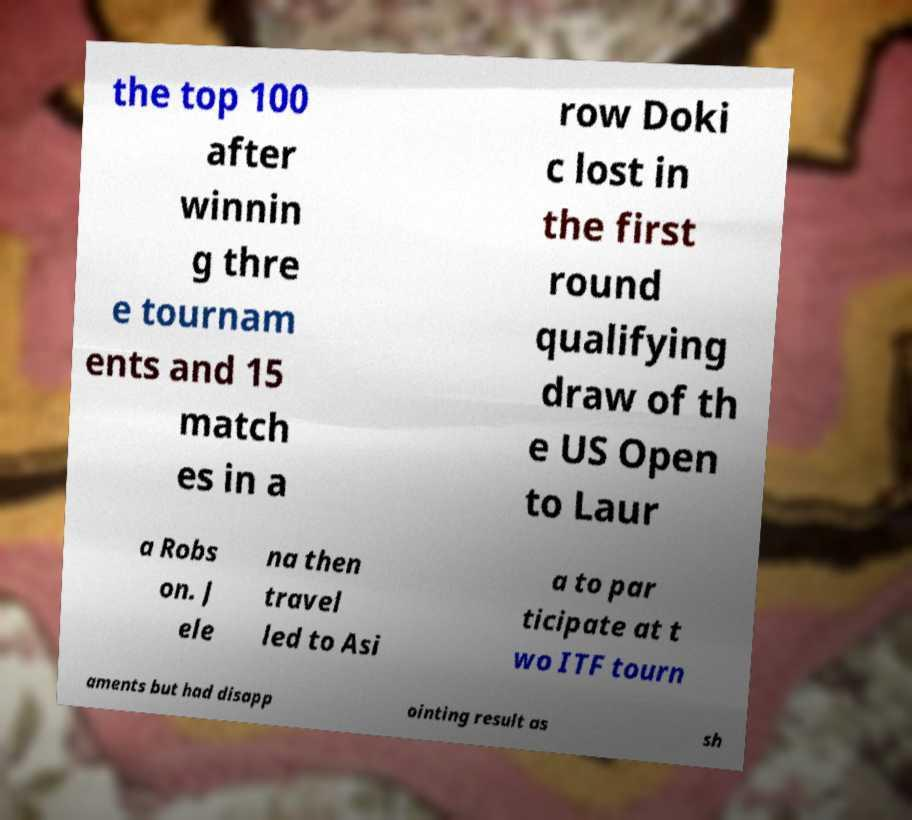For documentation purposes, I need the text within this image transcribed. Could you provide that? the top 100 after winnin g thre e tournam ents and 15 match es in a row Doki c lost in the first round qualifying draw of th e US Open to Laur a Robs on. J ele na then travel led to Asi a to par ticipate at t wo ITF tourn aments but had disapp ointing result as sh 